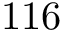<formula> <loc_0><loc_0><loc_500><loc_500>1 1 6</formula> 